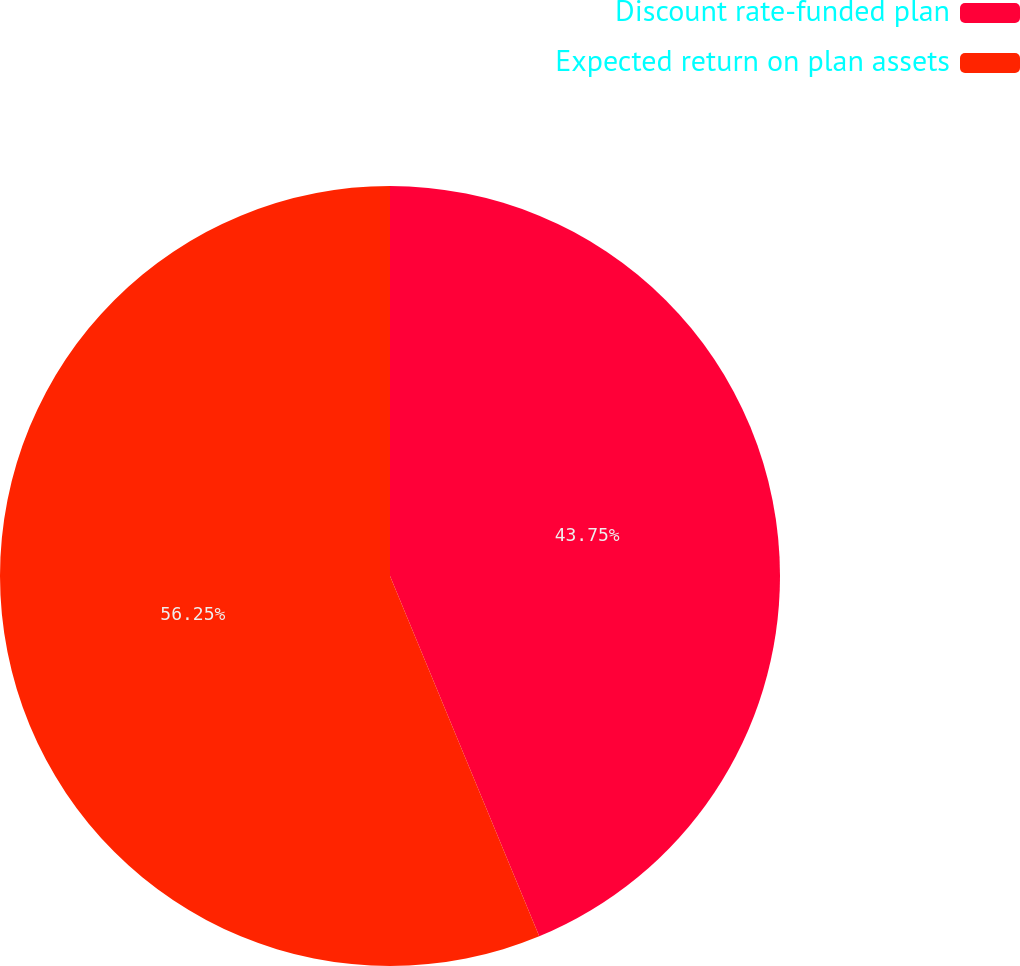Convert chart. <chart><loc_0><loc_0><loc_500><loc_500><pie_chart><fcel>Discount rate-funded plan<fcel>Expected return on plan assets<nl><fcel>43.75%<fcel>56.25%<nl></chart> 